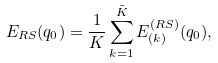Convert formula to latex. <formula><loc_0><loc_0><loc_500><loc_500>E _ { R S } ( q _ { 0 } ) = \frac { 1 } { K } \sum _ { k = 1 } ^ { \tilde { K } } E _ { ( k ) } ^ { ( R S ) } ( q _ { 0 } ) ,</formula> 